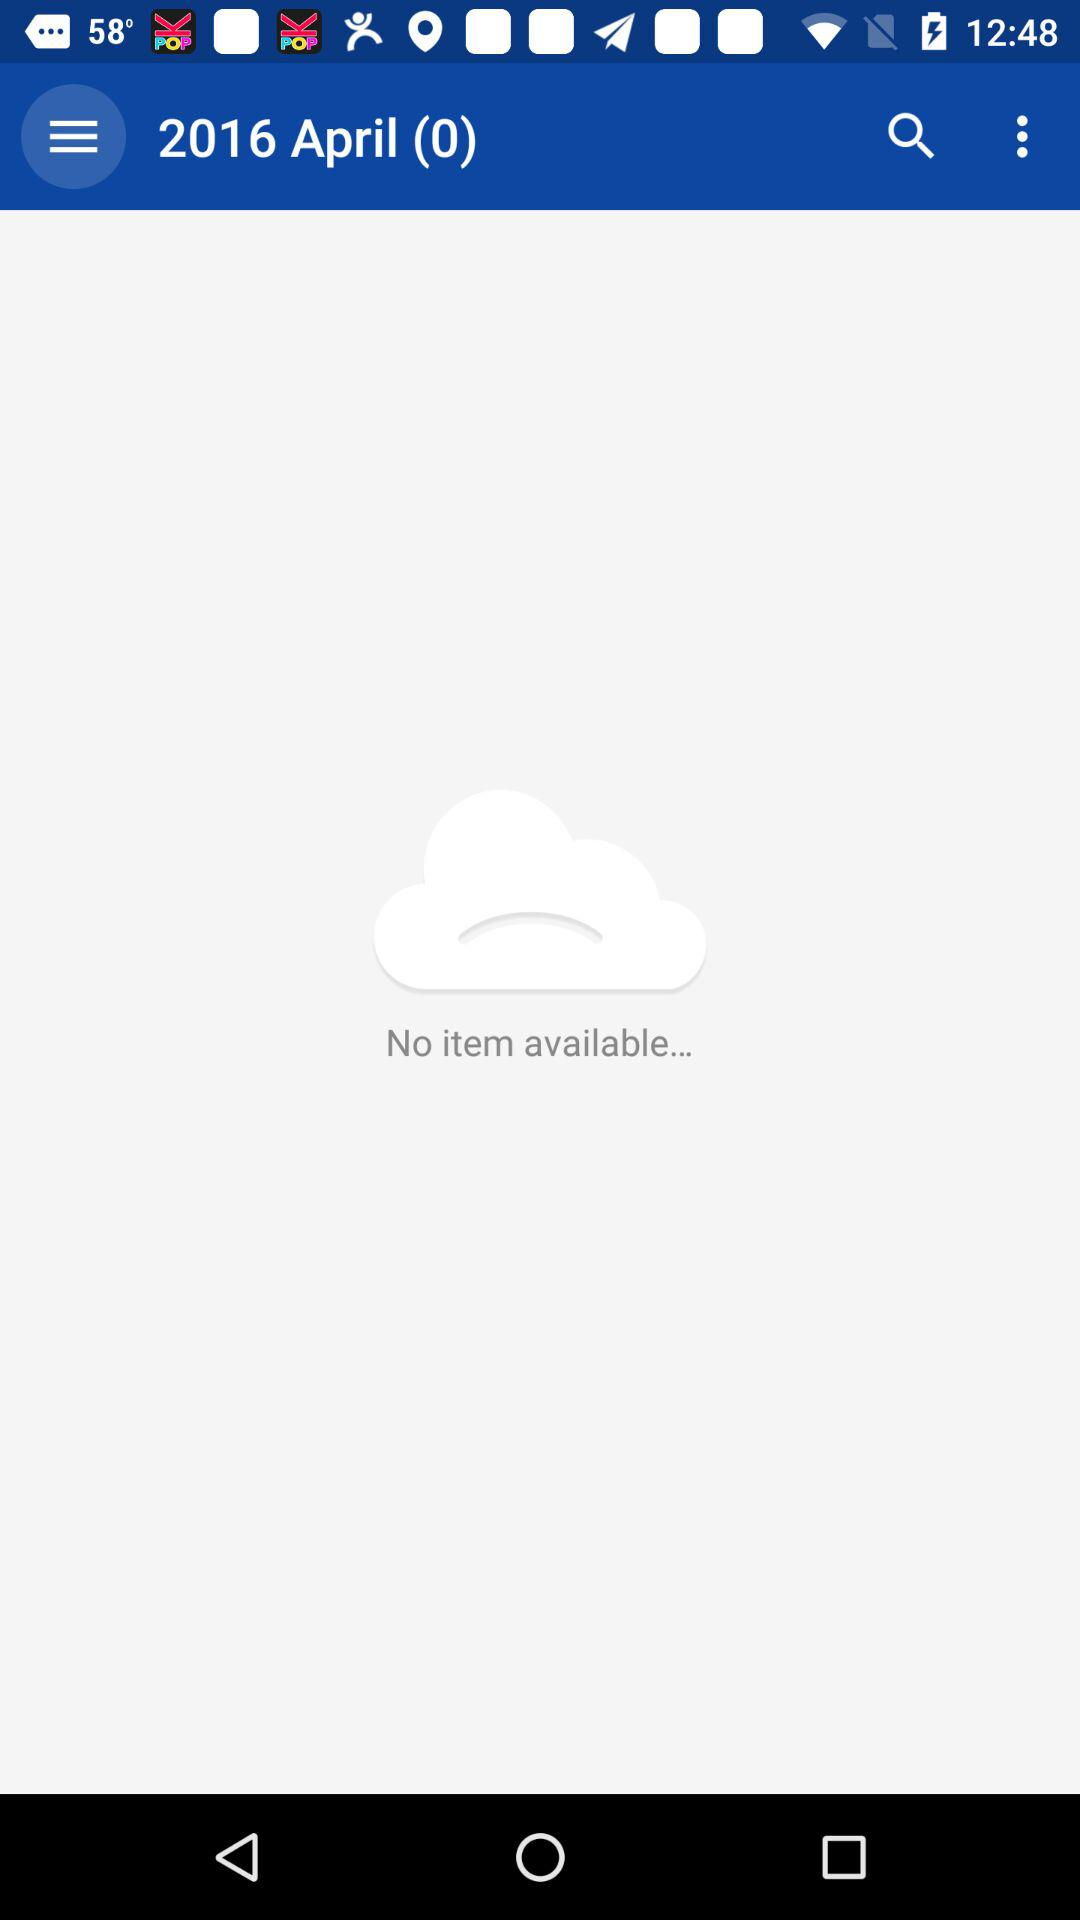What are the month and year shown on the screen? The month and year shown on the screen are April and 2016, respectively. 